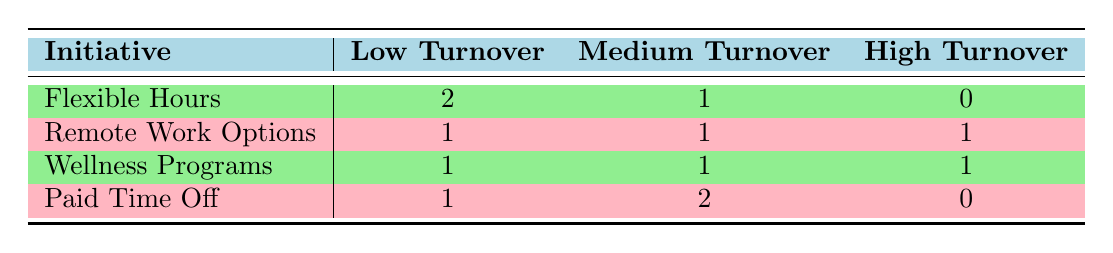What is the total number of employees with low turnover across all initiatives? From the table, we see that there are 2 employees with low turnover under "Flexible Hours," 1 under "Remote Work Options," 1 under "Wellness Programs," and 1 under "Paid Time Off." Summing these gives a total of 2 + 1 + 1 + 1 = 5 employees with low turnover.
Answer: 5 Which initiative has the highest number of employees with medium turnover? Looking at the table, "Paid Time Off" and "Flexible Hours" both have 2 employees with medium turnover. However, "Remote Work Options" and "Wellness Programs" each have only 1. Hence, "Paid Time Off" has the highest count.
Answer: Paid Time Off Is there any initiative that resulted in a high turnover? According to the table, "Remote Work Options" is the only initiative with 1 employee listed under high turnover, whereas the other initiatives either have none or do not reach that category. Thus, there is indeed an initiative with high turnover.
Answer: Yes What is the difference in the number of employees with low turnover and high turnover across all initiatives? The total number of employees with low turnover is 5, and there are 1 employee with high turnover. The difference is calculated as 5 - 1 = 4.
Answer: 4 How many total employees are listed under the "Wellness Programs" initiative? Under the "Wellness Programs" initiative, there are 3 employees recorded: Finance (Low), Sales (High), and Operations (Medium). Therefore, the total count is 3.
Answer: 3 Which type of turnover is most common among the employees under the "Remote Work Options"? From the information provided in the table for "Remote Work Options," there is 1 employee with low turnover, 1 with medium turnover, and 1 with high turnover. Therefore, all types of turnover are equally represented with 1 each.
Answer: None; all are equal What is the average number of employees with medium turnover across all initiatives? The number of employees with medium turnover is 1 for "Flexible Hours," 1 for "Remote Work Options," 1 for "Wellness Programs," and 2 for "Paid Time Off." Summing these gives 1 + 1 + 1 + 2 = 5, and there are 4 initiatives, so the average is 5 / 4 = 1.25.
Answer: 1.25 Is it true that every initiative has at least one employee with low turnover? Looking at the data, "Flexible Hours," "Remote Work Options," "Wellness Programs," and "Paid Time Off" all have at least one employee with low turnover (2, 1, 1, and 1 respectively). Therefore, the statement is true.
Answer: Yes 